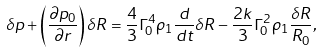<formula> <loc_0><loc_0><loc_500><loc_500>\delta p + \left ( \frac { \partial p _ { 0 } } { \partial r } \right ) \delta R = \frac { 4 } { 3 } \Gamma _ { 0 } ^ { 4 } \rho _ { 1 } \frac { d } { d t } \delta R - \frac { 2 k } { 3 } \Gamma _ { 0 } ^ { 2 } \rho _ { 1 } \frac { \delta R } { R _ { 0 } } ,</formula> 